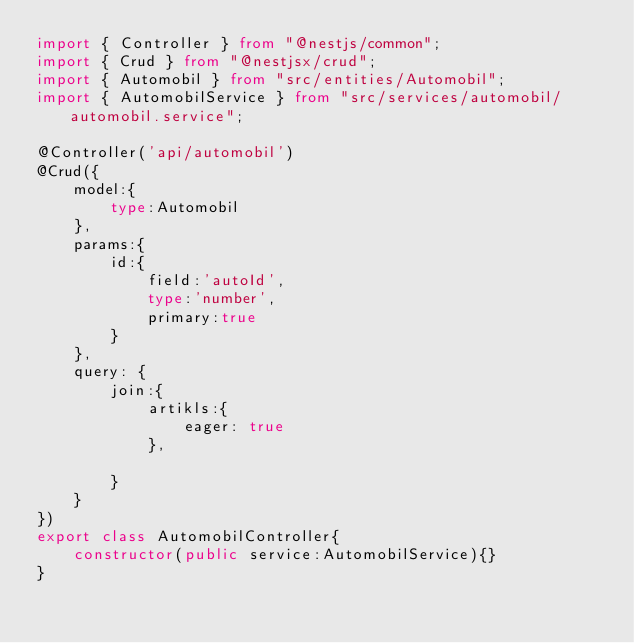Convert code to text. <code><loc_0><loc_0><loc_500><loc_500><_TypeScript_>import { Controller } from "@nestjs/common";
import { Crud } from "@nestjsx/crud";
import { Automobil } from "src/entities/Automobil";
import { AutomobilService } from "src/services/automobil/automobil.service";

@Controller('api/automobil')
@Crud({
    model:{
        type:Automobil
    },
    params:{
        id:{
            field:'autoId',
            type:'number',
            primary:true
        }
    },
    query: {
        join:{
            artikls:{
                eager: true
            },
         
        }
    }
})
export class AutomobilController{
    constructor(public service:AutomobilService){}
}</code> 